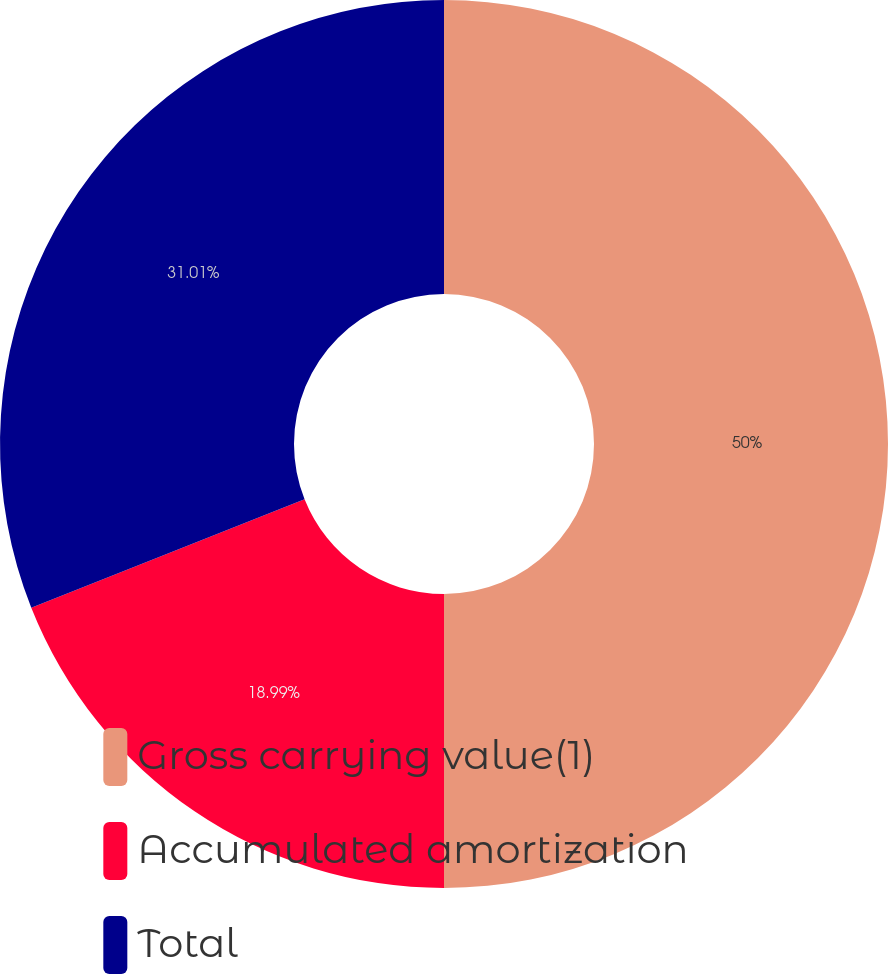<chart> <loc_0><loc_0><loc_500><loc_500><pie_chart><fcel>Gross carrying value(1)<fcel>Accumulated amortization<fcel>Total<nl><fcel>50.0%<fcel>18.99%<fcel>31.01%<nl></chart> 